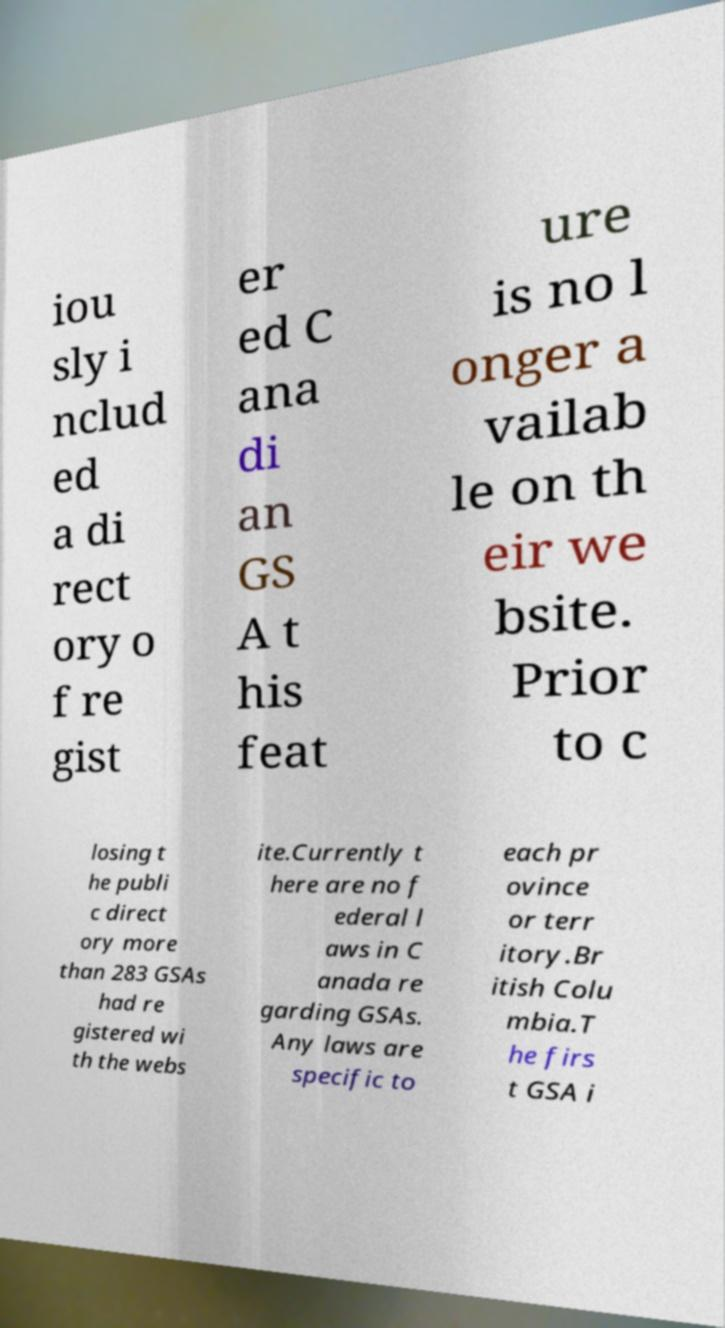Please identify and transcribe the text found in this image. iou sly i nclud ed a di rect ory o f re gist er ed C ana di an GS A t his feat ure is no l onger a vailab le on th eir we bsite. Prior to c losing t he publi c direct ory more than 283 GSAs had re gistered wi th the webs ite.Currently t here are no f ederal l aws in C anada re garding GSAs. Any laws are specific to each pr ovince or terr itory.Br itish Colu mbia.T he firs t GSA i 